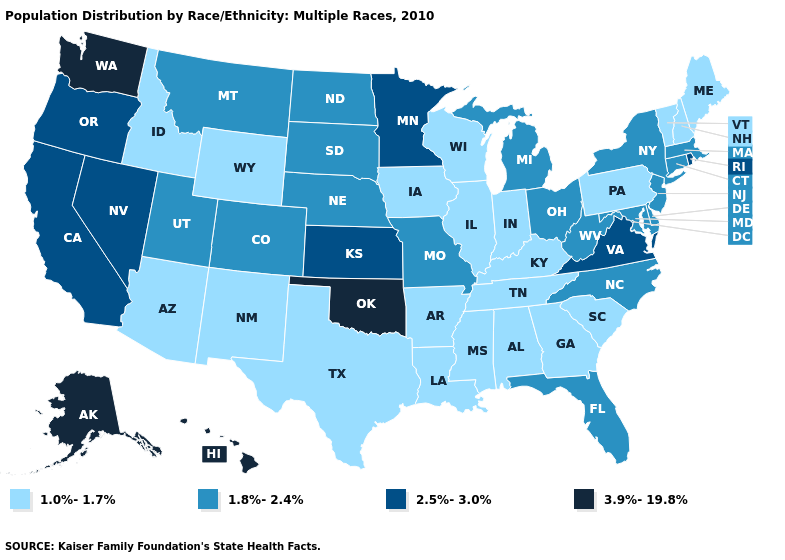Name the states that have a value in the range 2.5%-3.0%?
Be succinct. California, Kansas, Minnesota, Nevada, Oregon, Rhode Island, Virginia. Does the first symbol in the legend represent the smallest category?
Quick response, please. Yes. Does Kentucky have the highest value in the USA?
Keep it brief. No. What is the highest value in the USA?
Be succinct. 3.9%-19.8%. What is the value of Vermont?
Concise answer only. 1.0%-1.7%. Name the states that have a value in the range 3.9%-19.8%?
Give a very brief answer. Alaska, Hawaii, Oklahoma, Washington. What is the value of Kansas?
Short answer required. 2.5%-3.0%. Does Washington have the lowest value in the West?
Give a very brief answer. No. Name the states that have a value in the range 3.9%-19.8%?
Answer briefly. Alaska, Hawaii, Oklahoma, Washington. Does Missouri have the highest value in the MidWest?
Concise answer only. No. What is the value of Massachusetts?
Answer briefly. 1.8%-2.4%. Is the legend a continuous bar?
Answer briefly. No. What is the value of Massachusetts?
Keep it brief. 1.8%-2.4%. Does the first symbol in the legend represent the smallest category?
Quick response, please. Yes. What is the lowest value in the USA?
Short answer required. 1.0%-1.7%. 